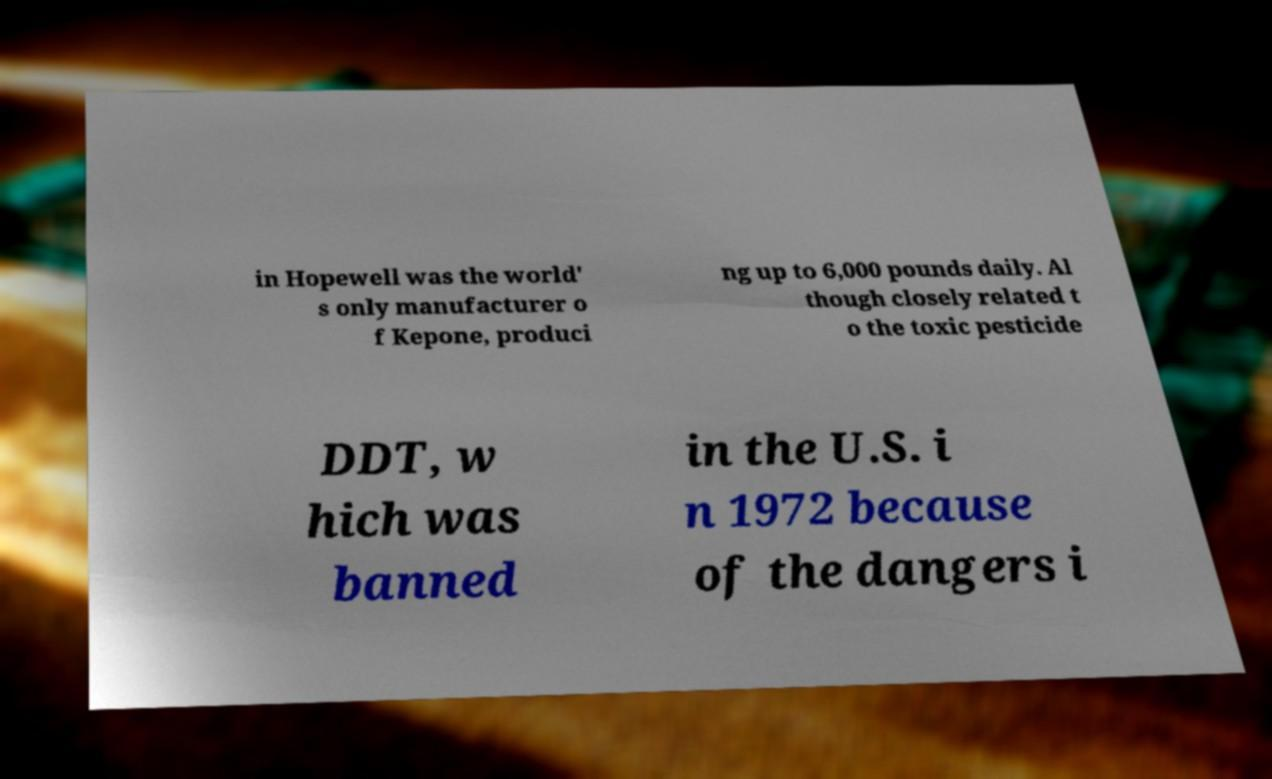Please identify and transcribe the text found in this image. in Hopewell was the world' s only manufacturer o f Kepone, produci ng up to 6,000 pounds daily. Al though closely related t o the toxic pesticide DDT, w hich was banned in the U.S. i n 1972 because of the dangers i 